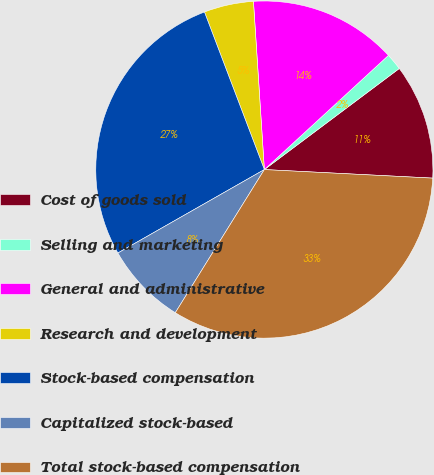<chart> <loc_0><loc_0><loc_500><loc_500><pie_chart><fcel>Cost of goods sold<fcel>Selling and marketing<fcel>General and administrative<fcel>Research and development<fcel>Stock-based compensation<fcel>Capitalized stock-based<fcel>Total stock-based compensation<nl><fcel>11.04%<fcel>1.61%<fcel>14.19%<fcel>4.75%<fcel>27.46%<fcel>7.9%<fcel>33.05%<nl></chart> 